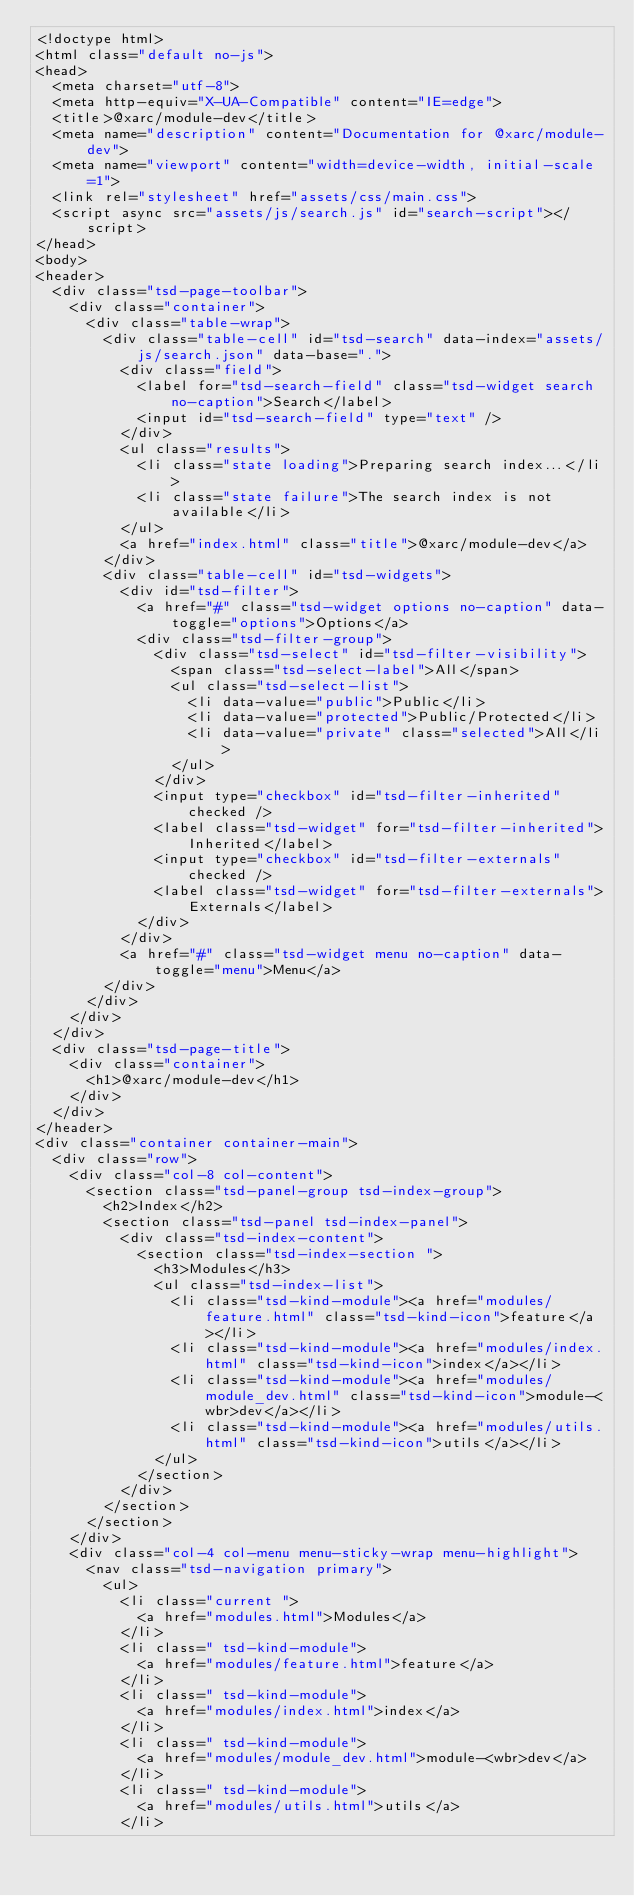Convert code to text. <code><loc_0><loc_0><loc_500><loc_500><_HTML_><!doctype html>
<html class="default no-js">
<head>
	<meta charset="utf-8">
	<meta http-equiv="X-UA-Compatible" content="IE=edge">
	<title>@xarc/module-dev</title>
	<meta name="description" content="Documentation for @xarc/module-dev">
	<meta name="viewport" content="width=device-width, initial-scale=1">
	<link rel="stylesheet" href="assets/css/main.css">
	<script async src="assets/js/search.js" id="search-script"></script>
</head>
<body>
<header>
	<div class="tsd-page-toolbar">
		<div class="container">
			<div class="table-wrap">
				<div class="table-cell" id="tsd-search" data-index="assets/js/search.json" data-base=".">
					<div class="field">
						<label for="tsd-search-field" class="tsd-widget search no-caption">Search</label>
						<input id="tsd-search-field" type="text" />
					</div>
					<ul class="results">
						<li class="state loading">Preparing search index...</li>
						<li class="state failure">The search index is not available</li>
					</ul>
					<a href="index.html" class="title">@xarc/module-dev</a>
				</div>
				<div class="table-cell" id="tsd-widgets">
					<div id="tsd-filter">
						<a href="#" class="tsd-widget options no-caption" data-toggle="options">Options</a>
						<div class="tsd-filter-group">
							<div class="tsd-select" id="tsd-filter-visibility">
								<span class="tsd-select-label">All</span>
								<ul class="tsd-select-list">
									<li data-value="public">Public</li>
									<li data-value="protected">Public/Protected</li>
									<li data-value="private" class="selected">All</li>
								</ul>
							</div>
							<input type="checkbox" id="tsd-filter-inherited" checked />
							<label class="tsd-widget" for="tsd-filter-inherited">Inherited</label>
							<input type="checkbox" id="tsd-filter-externals" checked />
							<label class="tsd-widget" for="tsd-filter-externals">Externals</label>
						</div>
					</div>
					<a href="#" class="tsd-widget menu no-caption" data-toggle="menu">Menu</a>
				</div>
			</div>
		</div>
	</div>
	<div class="tsd-page-title">
		<div class="container">
			<h1>@xarc/module-dev</h1>
		</div>
	</div>
</header>
<div class="container container-main">
	<div class="row">
		<div class="col-8 col-content">
			<section class="tsd-panel-group tsd-index-group">
				<h2>Index</h2>
				<section class="tsd-panel tsd-index-panel">
					<div class="tsd-index-content">
						<section class="tsd-index-section ">
							<h3>Modules</h3>
							<ul class="tsd-index-list">
								<li class="tsd-kind-module"><a href="modules/feature.html" class="tsd-kind-icon">feature</a></li>
								<li class="tsd-kind-module"><a href="modules/index.html" class="tsd-kind-icon">index</a></li>
								<li class="tsd-kind-module"><a href="modules/module_dev.html" class="tsd-kind-icon">module-<wbr>dev</a></li>
								<li class="tsd-kind-module"><a href="modules/utils.html" class="tsd-kind-icon">utils</a></li>
							</ul>
						</section>
					</div>
				</section>
			</section>
		</div>
		<div class="col-4 col-menu menu-sticky-wrap menu-highlight">
			<nav class="tsd-navigation primary">
				<ul>
					<li class="current ">
						<a href="modules.html">Modules</a>
					</li>
					<li class=" tsd-kind-module">
						<a href="modules/feature.html">feature</a>
					</li>
					<li class=" tsd-kind-module">
						<a href="modules/index.html">index</a>
					</li>
					<li class=" tsd-kind-module">
						<a href="modules/module_dev.html">module-<wbr>dev</a>
					</li>
					<li class=" tsd-kind-module">
						<a href="modules/utils.html">utils</a>
					</li></code> 